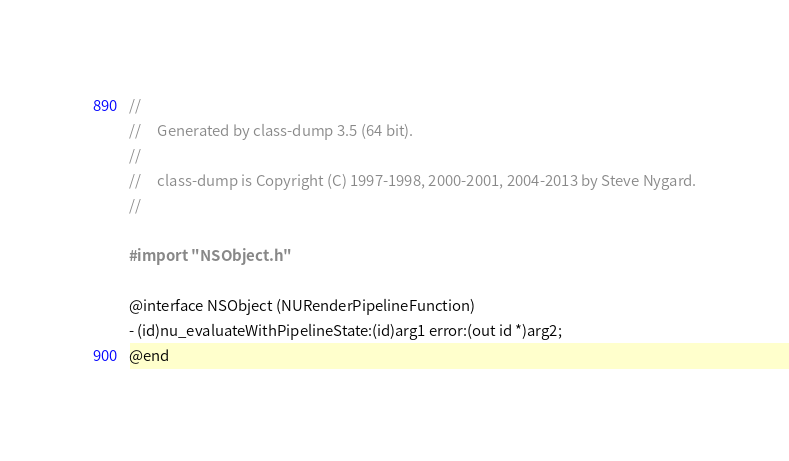Convert code to text. <code><loc_0><loc_0><loc_500><loc_500><_C_>//
//     Generated by class-dump 3.5 (64 bit).
//
//     class-dump is Copyright (C) 1997-1998, 2000-2001, 2004-2013 by Steve Nygard.
//

#import "NSObject.h"

@interface NSObject (NURenderPipelineFunction)
- (id)nu_evaluateWithPipelineState:(id)arg1 error:(out id *)arg2;
@end

</code> 